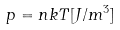<formula> <loc_0><loc_0><loc_500><loc_500>p = n k T [ J / m ^ { 3 } ]</formula> 